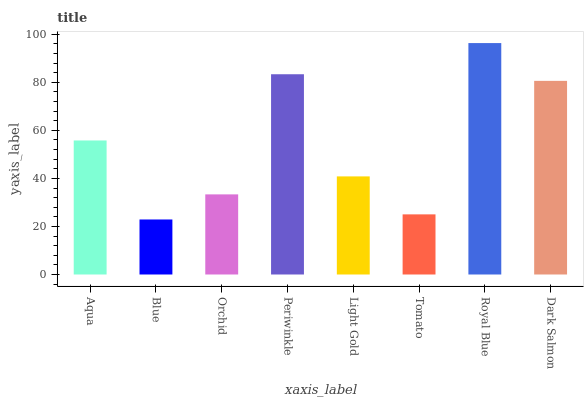Is Blue the minimum?
Answer yes or no. Yes. Is Royal Blue the maximum?
Answer yes or no. Yes. Is Orchid the minimum?
Answer yes or no. No. Is Orchid the maximum?
Answer yes or no. No. Is Orchid greater than Blue?
Answer yes or no. Yes. Is Blue less than Orchid?
Answer yes or no. Yes. Is Blue greater than Orchid?
Answer yes or no. No. Is Orchid less than Blue?
Answer yes or no. No. Is Aqua the high median?
Answer yes or no. Yes. Is Light Gold the low median?
Answer yes or no. Yes. Is Tomato the high median?
Answer yes or no. No. Is Periwinkle the low median?
Answer yes or no. No. 